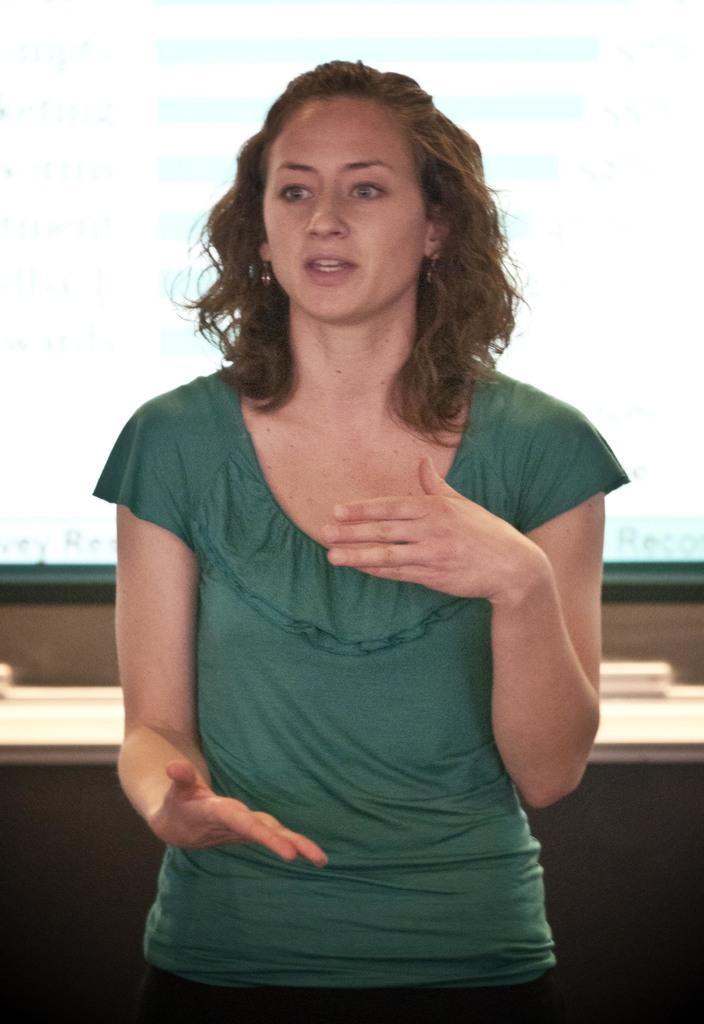Can you describe this image briefly? In the picture we can see a woman standing and she is wearing a green dress and has a brown hair and explaining something and in the background we can see a glass window near the desk. 